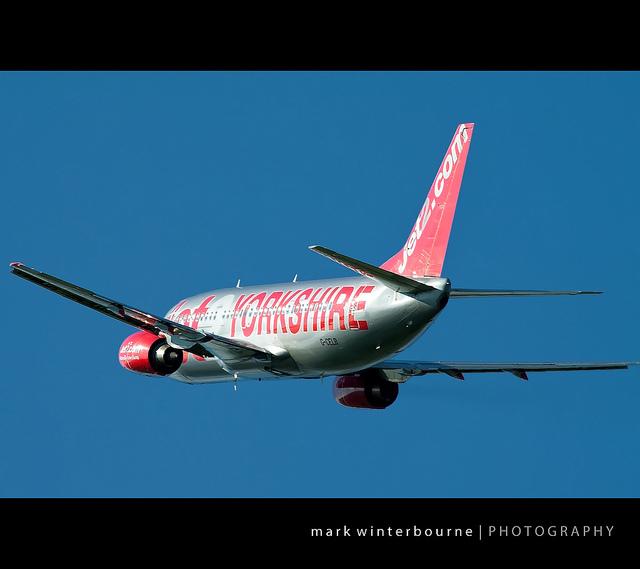What color are the words on the plane?
Quick response, please. Red. What word is written on the plane?
Be succinct. Yorkshire. What airliner is shown?
Keep it brief. Yorkshire. 